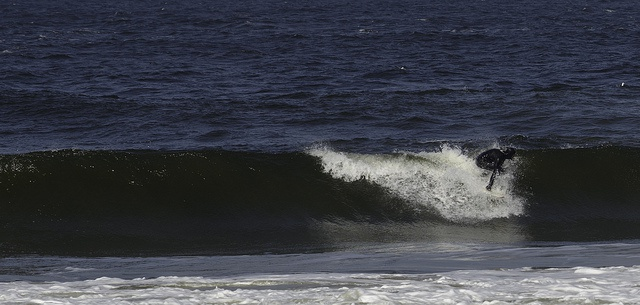Describe the objects in this image and their specific colors. I can see people in black, gray, and darkgray tones and surfboard in black, darkgray, and gray tones in this image. 